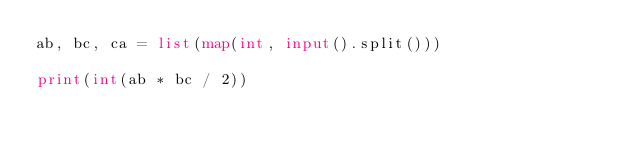Convert code to text. <code><loc_0><loc_0><loc_500><loc_500><_Python_>ab, bc, ca = list(map(int, input().split()))
 
print(int(ab * bc / 2))</code> 